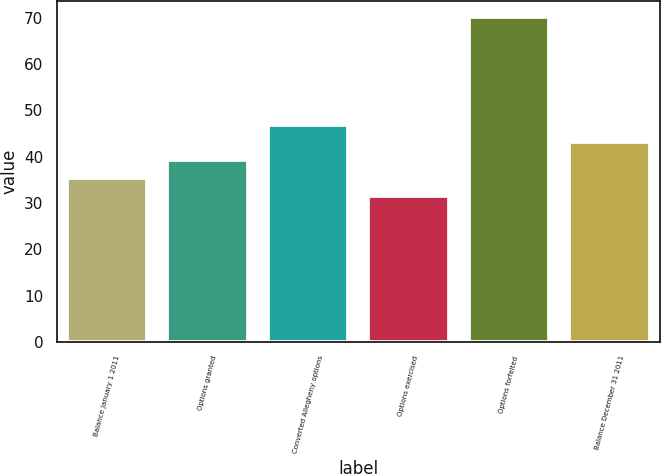Convert chart to OTSL. <chart><loc_0><loc_0><loc_500><loc_500><bar_chart><fcel>Balance January 1 2011<fcel>Options granted<fcel>Converted Allegheny options<fcel>Options exercised<fcel>Options forfeited<fcel>Balance December 31 2011<nl><fcel>35.35<fcel>39.22<fcel>46.96<fcel>31.48<fcel>70.19<fcel>43.09<nl></chart> 